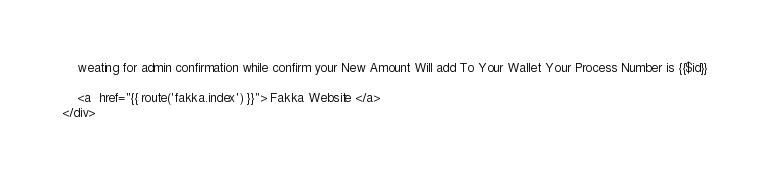<code> <loc_0><loc_0><loc_500><loc_500><_PHP_>    weating for admin confirmation while confirm your New Amount Will add To Your Wallet Your Process Number is {{$id}}

    <a  href="{{ route('fakka.index') }}"> Fakka Website </a>
</div>



</code> 